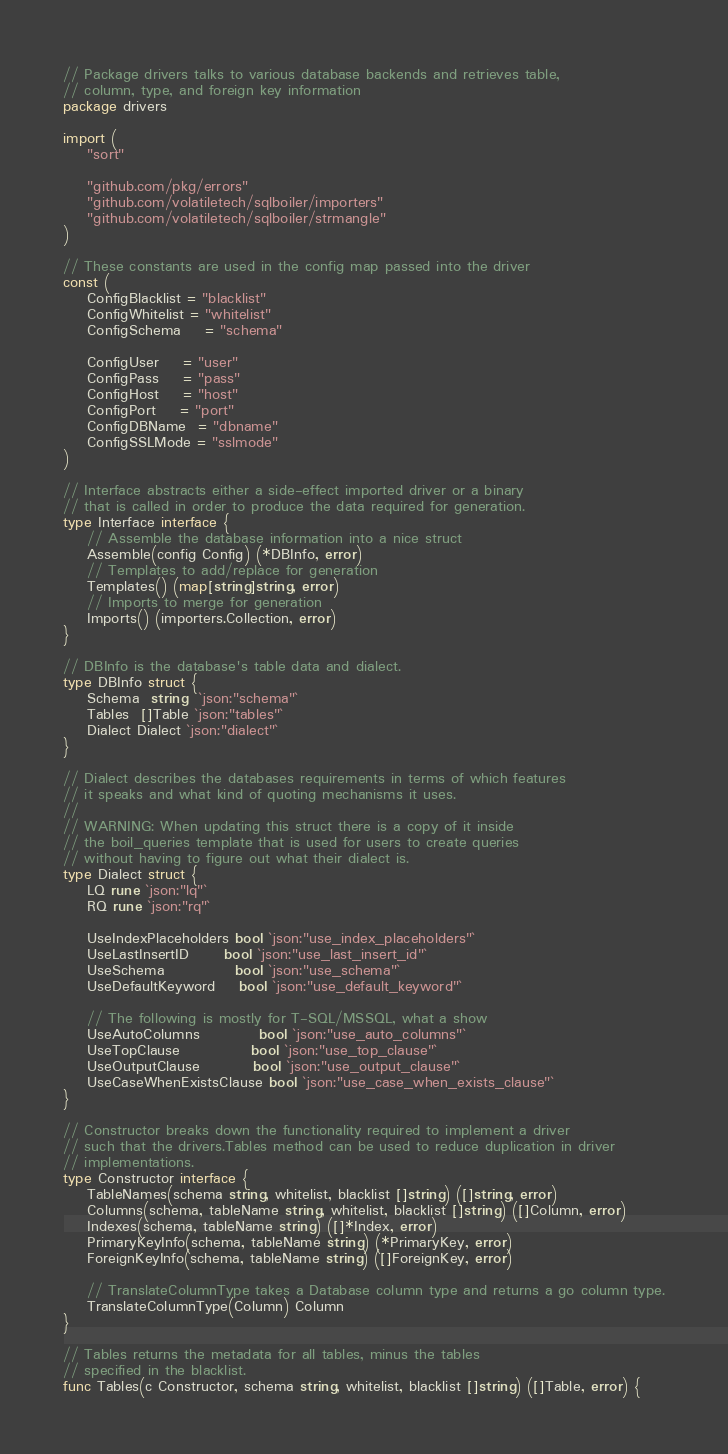<code> <loc_0><loc_0><loc_500><loc_500><_Go_>// Package drivers talks to various database backends and retrieves table,
// column, type, and foreign key information
package drivers

import (
	"sort"

	"github.com/pkg/errors"
	"github.com/volatiletech/sqlboiler/importers"
	"github.com/volatiletech/sqlboiler/strmangle"
)

// These constants are used in the config map passed into the driver
const (
	ConfigBlacklist = "blacklist"
	ConfigWhitelist = "whitelist"
	ConfigSchema    = "schema"

	ConfigUser    = "user"
	ConfigPass    = "pass"
	ConfigHost    = "host"
	ConfigPort    = "port"
	ConfigDBName  = "dbname"
	ConfigSSLMode = "sslmode"
)

// Interface abstracts either a side-effect imported driver or a binary
// that is called in order to produce the data required for generation.
type Interface interface {
	// Assemble the database information into a nice struct
	Assemble(config Config) (*DBInfo, error)
	// Templates to add/replace for generation
	Templates() (map[string]string, error)
	// Imports to merge for generation
	Imports() (importers.Collection, error)
}

// DBInfo is the database's table data and dialect.
type DBInfo struct {
	Schema  string  `json:"schema"`
	Tables  []Table `json:"tables"`
	Dialect Dialect `json:"dialect"`
}

// Dialect describes the databases requirements in terms of which features
// it speaks and what kind of quoting mechanisms it uses.
//
// WARNING: When updating this struct there is a copy of it inside
// the boil_queries template that is used for users to create queries
// without having to figure out what their dialect is.
type Dialect struct {
	LQ rune `json:"lq"`
	RQ rune `json:"rq"`

	UseIndexPlaceholders bool `json:"use_index_placeholders"`
	UseLastInsertID      bool `json:"use_last_insert_id"`
	UseSchema            bool `json:"use_schema"`
	UseDefaultKeyword    bool `json:"use_default_keyword"`

	// The following is mostly for T-SQL/MSSQL, what a show
	UseAutoColumns          bool `json:"use_auto_columns"`
	UseTopClause            bool `json:"use_top_clause"`
	UseOutputClause         bool `json:"use_output_clause"`
	UseCaseWhenExistsClause bool `json:"use_case_when_exists_clause"`
}

// Constructor breaks down the functionality required to implement a driver
// such that the drivers.Tables method can be used to reduce duplication in driver
// implementations.
type Constructor interface {
	TableNames(schema string, whitelist, blacklist []string) ([]string, error)
	Columns(schema, tableName string, whitelist, blacklist []string) ([]Column, error)
	Indexes(schema, tableName string) ([]*Index, error)
	PrimaryKeyInfo(schema, tableName string) (*PrimaryKey, error)
	ForeignKeyInfo(schema, tableName string) ([]ForeignKey, error)

	// TranslateColumnType takes a Database column type and returns a go column type.
	TranslateColumnType(Column) Column
}

// Tables returns the metadata for all tables, minus the tables
// specified in the blacklist.
func Tables(c Constructor, schema string, whitelist, blacklist []string) ([]Table, error) {</code> 